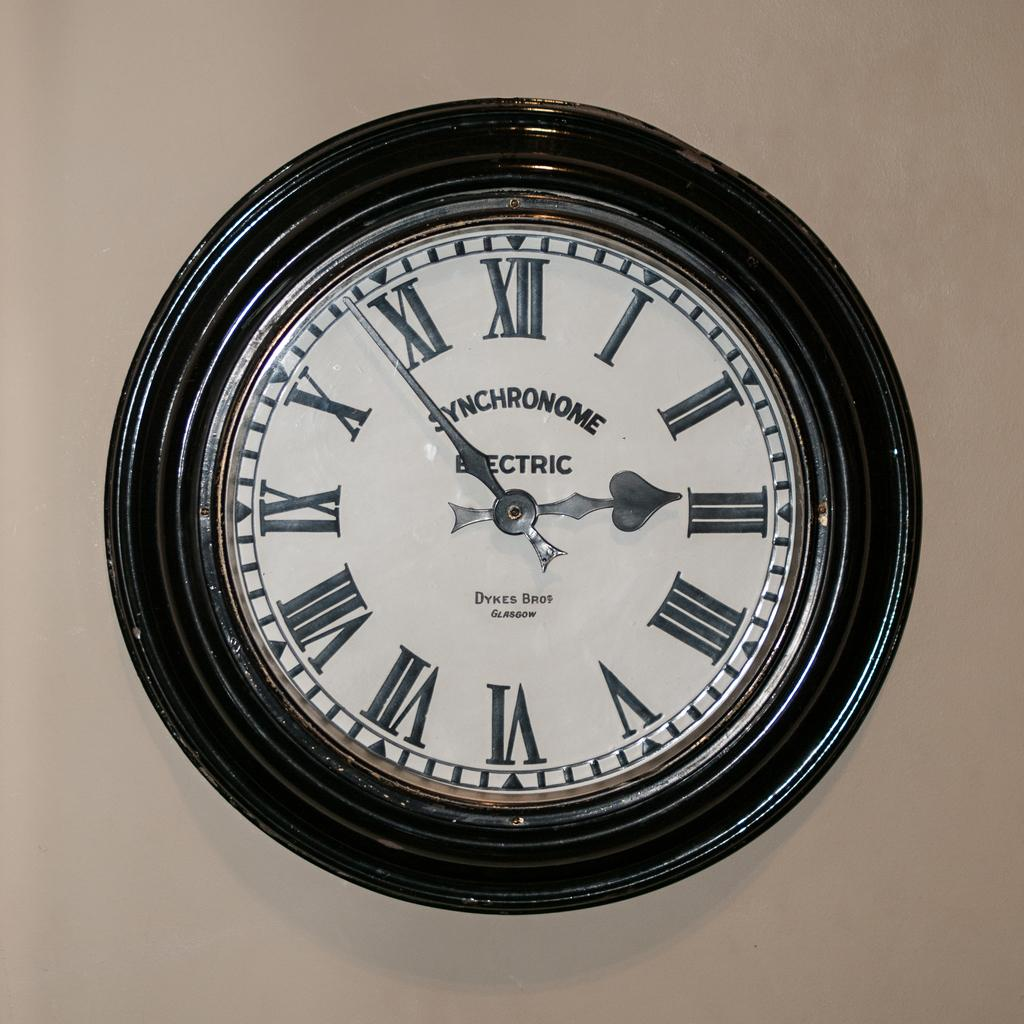<image>
Create a compact narrative representing the image presented. An Black rimmed electric Synchronome clock set to 2:53 